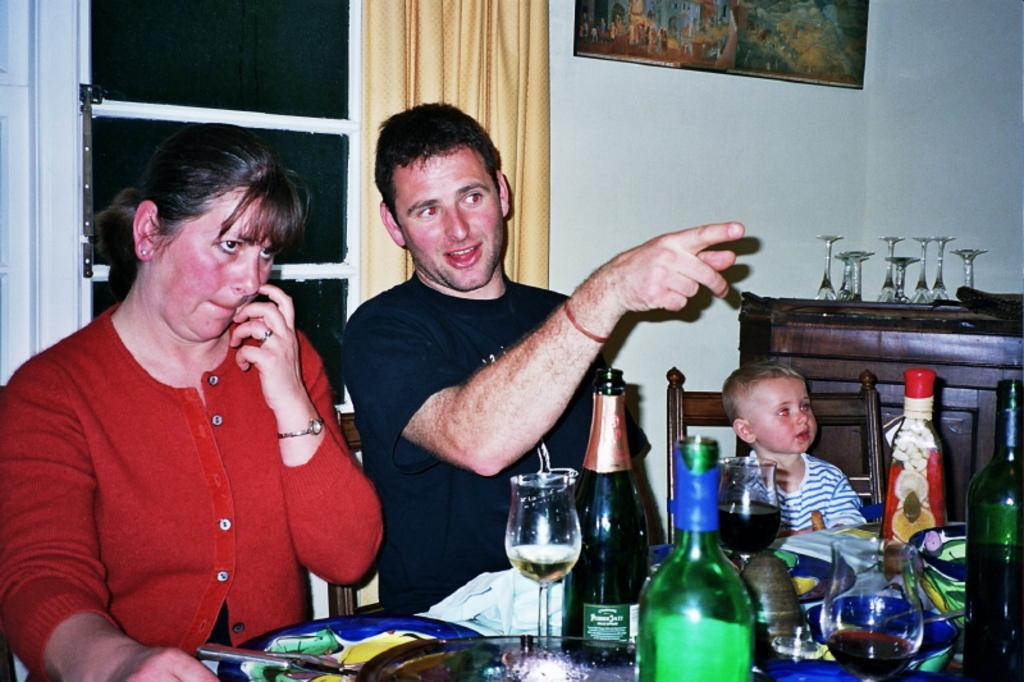Could you give a brief overview of what you see in this image? There is a man and a woman sitting in the chairs in front of a table on which glasses, bottles and some accessories were placed. There is a kid beside them in the chair. In the background there is a wall curtain and a photo frame attached to the wall. 